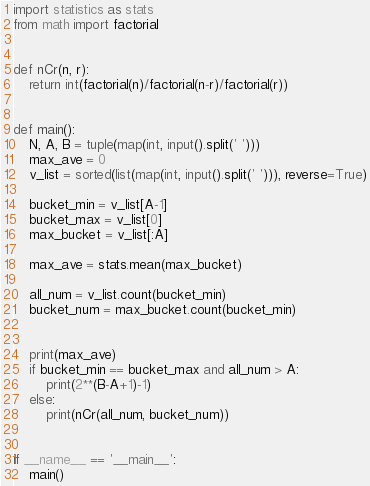Convert code to text. <code><loc_0><loc_0><loc_500><loc_500><_Python_>import statistics as stats
from math import factorial


def nCr(n, r):
    return int(factorial(n)/factorial(n-r)/factorial(r))


def main():
    N, A, B = tuple(map(int, input().split(' ')))
    max_ave = 0
    v_list = sorted(list(map(int, input().split(' '))), reverse=True)

    bucket_min = v_list[A-1]
    bucket_max = v_list[0]
    max_bucket = v_list[:A]

    max_ave = stats.mean(max_bucket)

    all_num = v_list.count(bucket_min)
    bucket_num = max_bucket.count(bucket_min)


    print(max_ave)
    if bucket_min == bucket_max and all_num > A:
        print(2**(B-A+1)-1)
    else:
        print(nCr(all_num, bucket_num))


if __name__ == '__main__':
    main()
</code> 